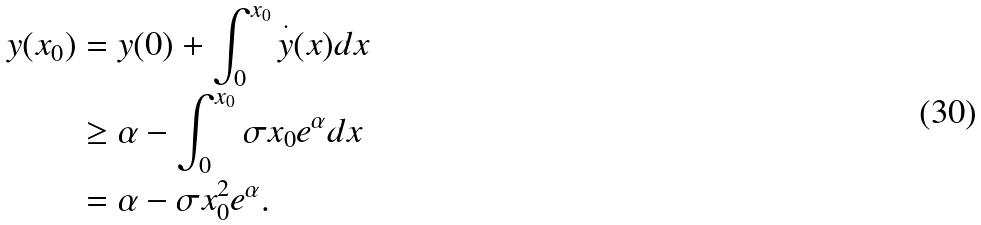<formula> <loc_0><loc_0><loc_500><loc_500>y ( x _ { 0 } ) & = y ( 0 ) + \int _ { 0 } ^ { x _ { 0 } } \overset { \cdot } { y } ( x ) d x \\ & \geq \alpha - \int _ { 0 } ^ { x _ { 0 } } \sigma x _ { 0 } e ^ { \alpha } d x \\ & = \alpha - \sigma x _ { 0 } ^ { 2 } e ^ { \alpha } .</formula> 